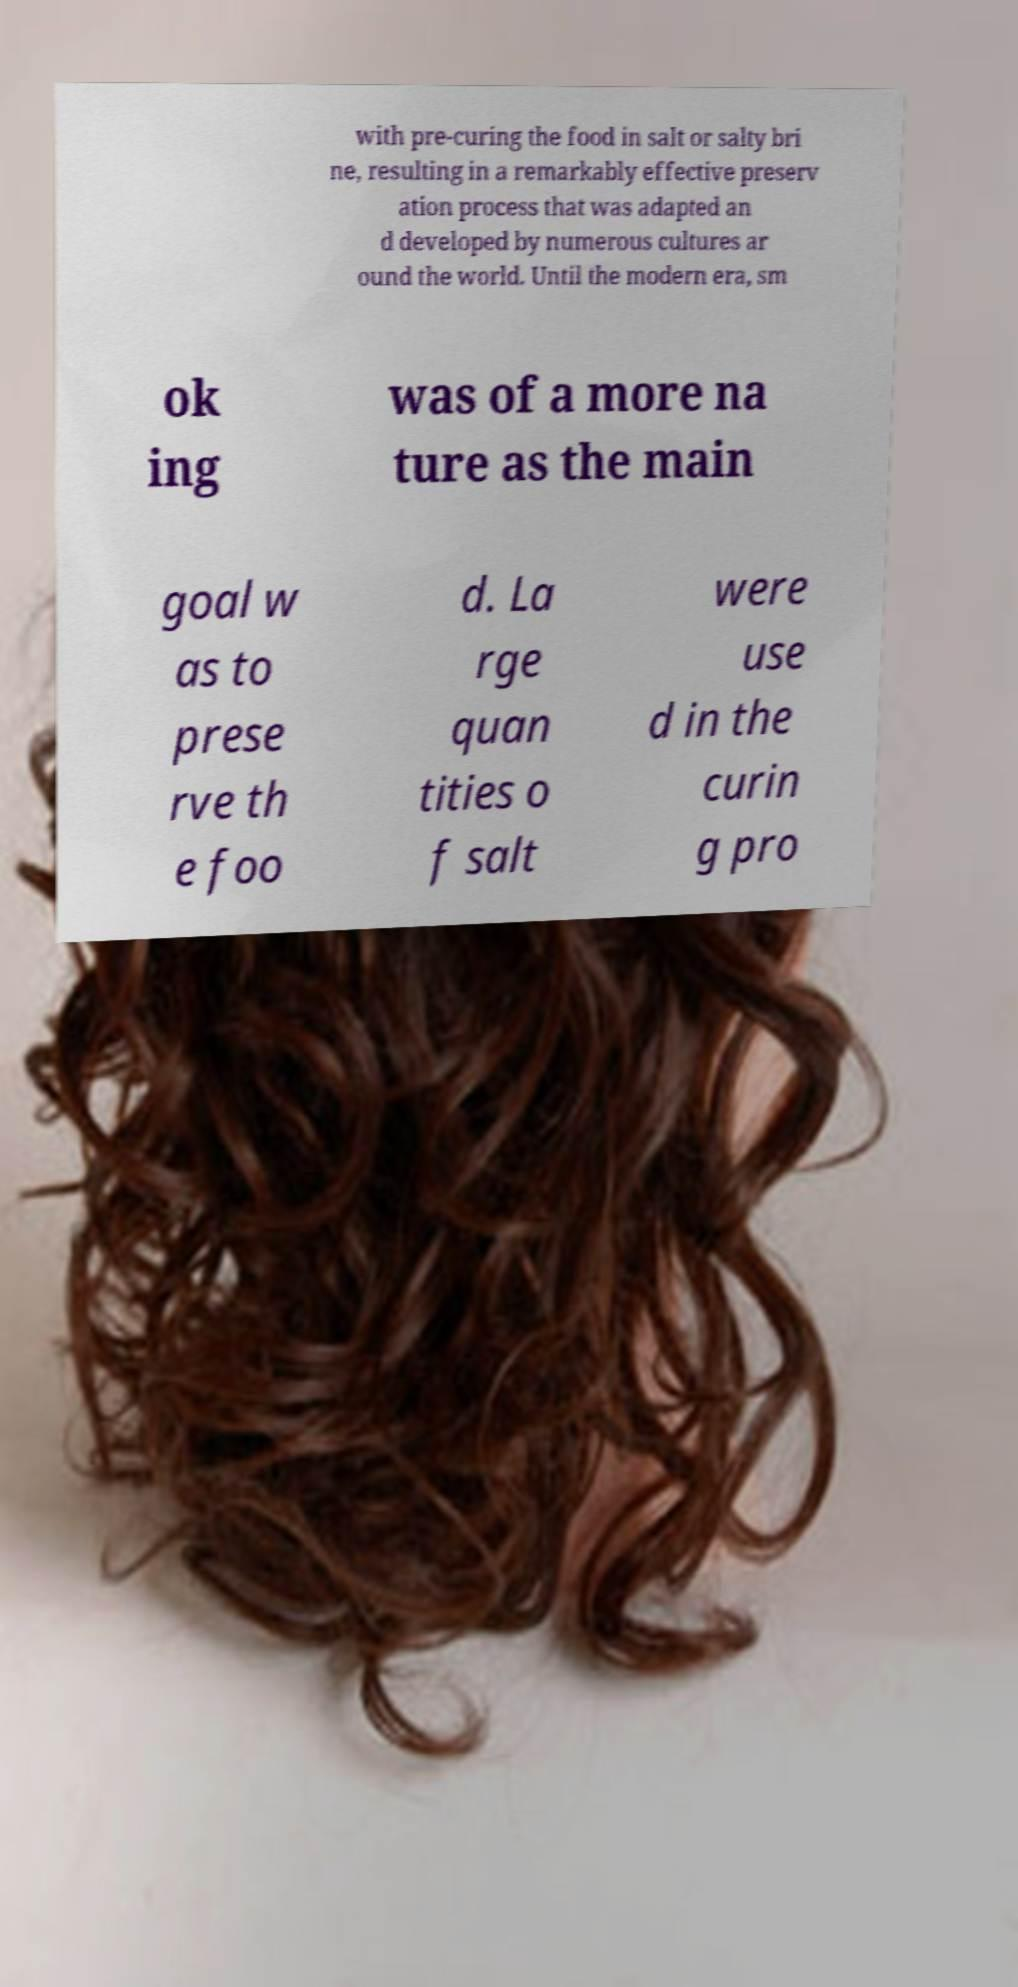Could you assist in decoding the text presented in this image and type it out clearly? with pre-curing the food in salt or salty bri ne, resulting in a remarkably effective preserv ation process that was adapted an d developed by numerous cultures ar ound the world. Until the modern era, sm ok ing was of a more na ture as the main goal w as to prese rve th e foo d. La rge quan tities o f salt were use d in the curin g pro 